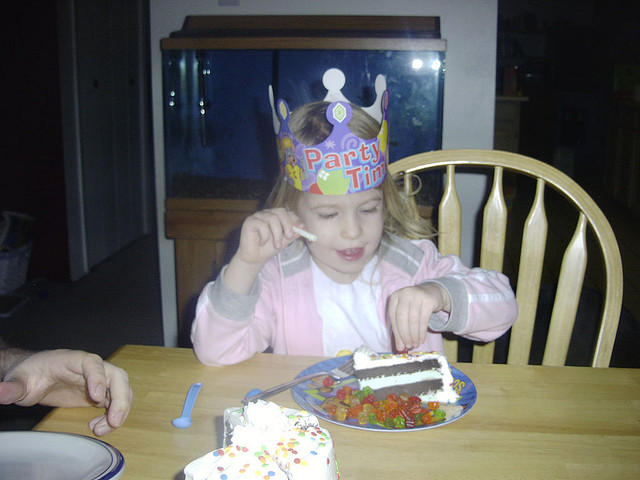Please transcribe the text in this image. Party Tim 